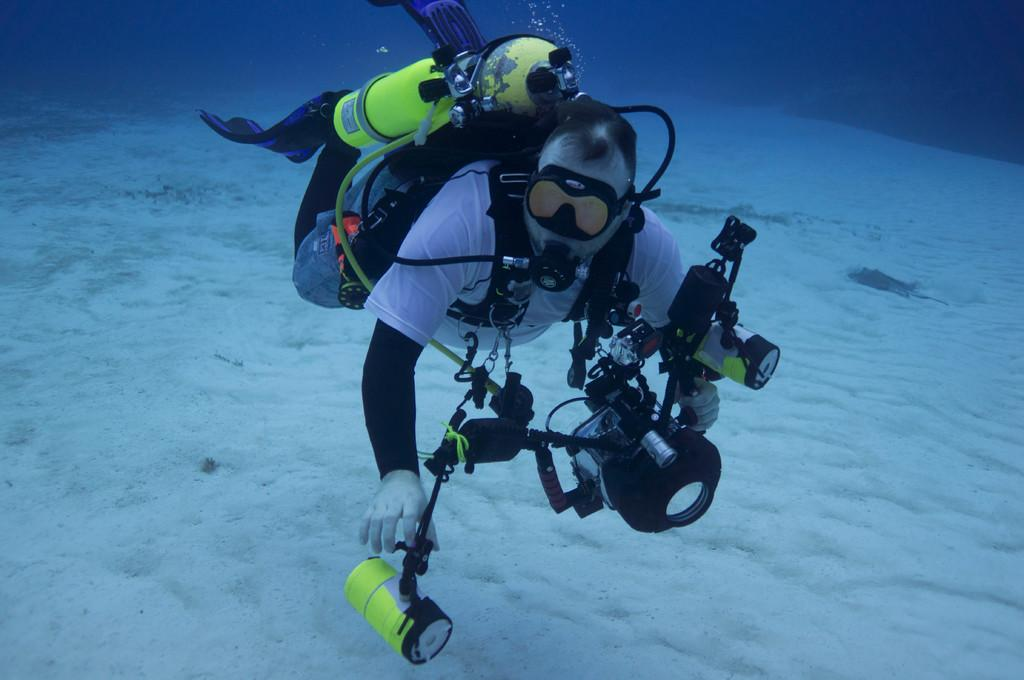What is the person in the image doing? The person is in the water. What is the person wearing on their upper body? The person is wearing a white shirt. What type of gloves is the person wearing? The person is wearing white gloves. What equipment is the person using in the water? The person is wearing an oxygen cylinder. What type of bat can be seen flying over the person in the image? There is no bat present in the image. How many bats are in the flock flying over the person in the image? There are no bats present in the image, so it is not possible to determine the number of bats in a flock. 